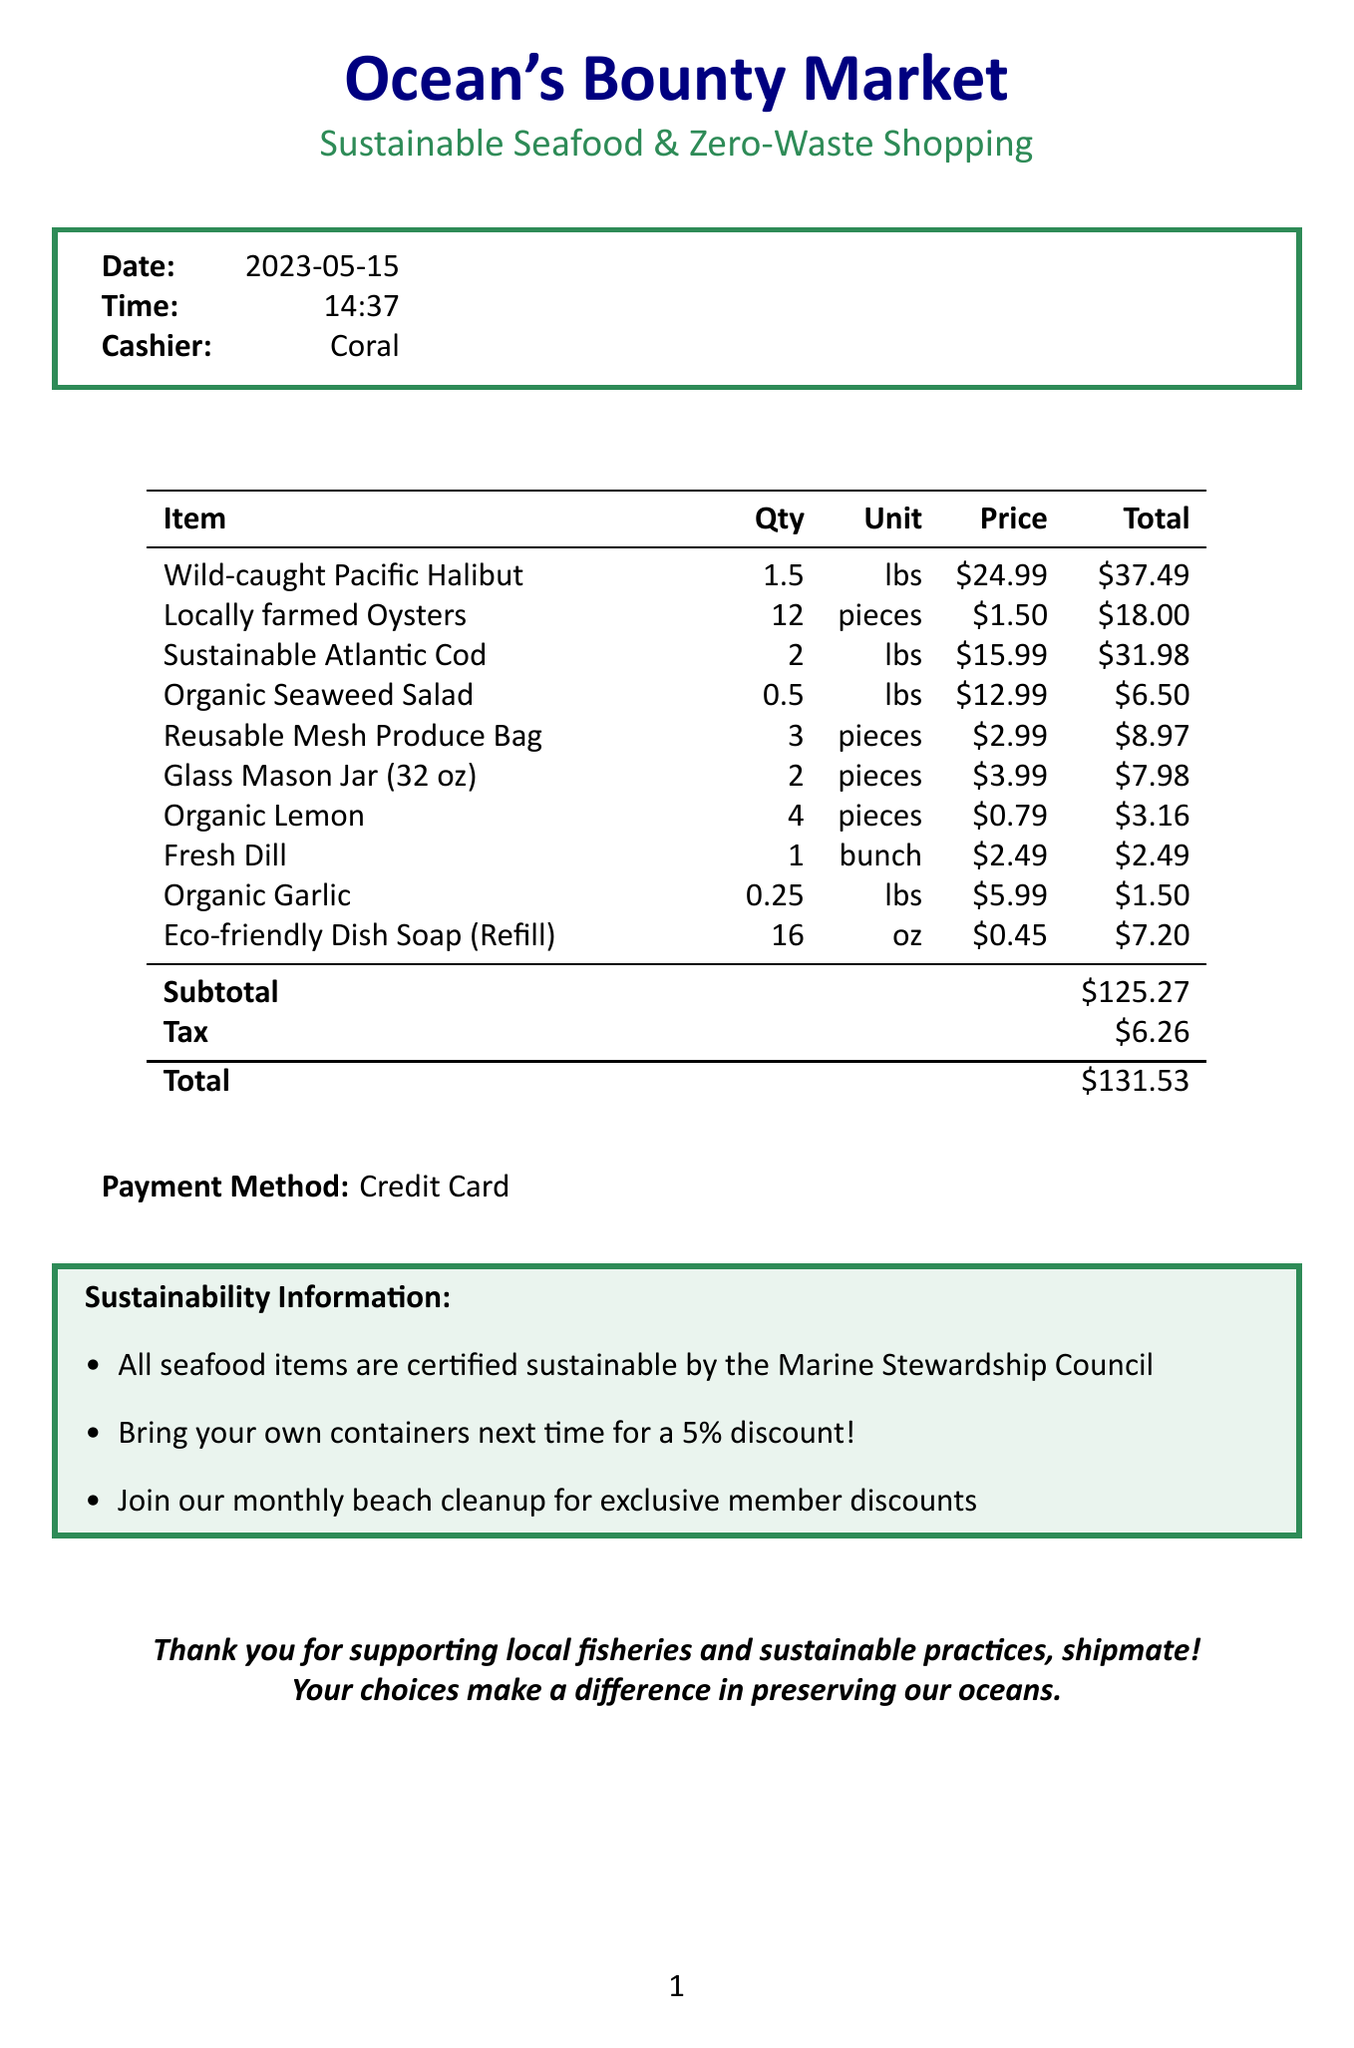What is the store name? The store name is located at the top of the document.
Answer: Ocean's Bounty Market What date was the shopping trip? The date is listed in the receipt details section.
Answer: 2023-05-15 Who was the cashier? The cashier's name is provided in the document.
Answer: Coral What is the total amount spent? The total amount is shown in the summary at the bottom of the receipt.
Answer: $131.53 How many pieces of locally farmed oysters were bought? The quantity of oysters is specified in the itemized list.
Answer: 12 What discount is offered for bringing own containers? The discount information is noted in the sustainability info section.
Answer: 5% discount How many gallons is the glass mason jar? The size of the mason jar is mentioned in the itemized list.
Answer: 32 oz What is included in the sustainability information? The sustainability info section lists multiple points regarding sustainable practices.
Answer: Certified sustainable by the Marine Stewardship Council What is the payment method used? The payment method is highlighted in the summary of the receipt.
Answer: Credit Card 